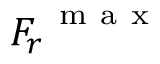<formula> <loc_0><loc_0><loc_500><loc_500>{ F _ { r } } ^ { m a x }</formula> 